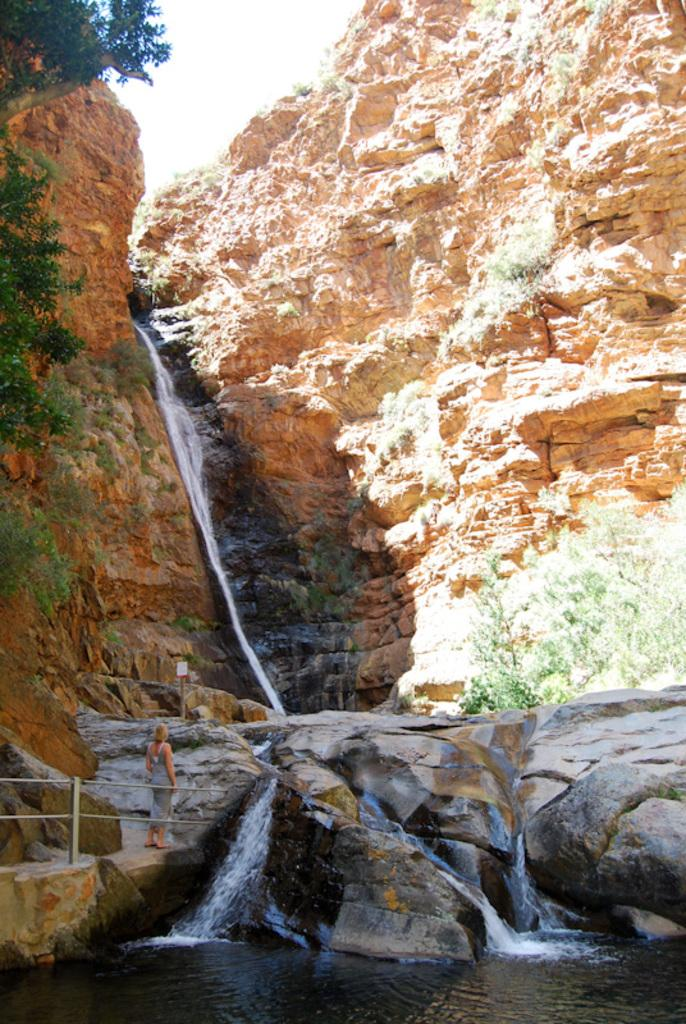What can be seen at the top of the image? The sky is visible at the top of the image. What type of natural landforms are present in the image? There are mountains in the image. What specific feature can be observed on the mountains? There are waterfalls on the mountains. Who is present in the image? A woman is standing in the image. What type of barrier is visible in the image? There is a fence in the image. What is the primary liquid element present in the image? Water is present in the image. What type of comb is the woman using to brush her hair in the image? There is no comb visible in the image, and the woman's hair is not being brushed. How many stars can be seen in the image? There are no stars visible in the image. 